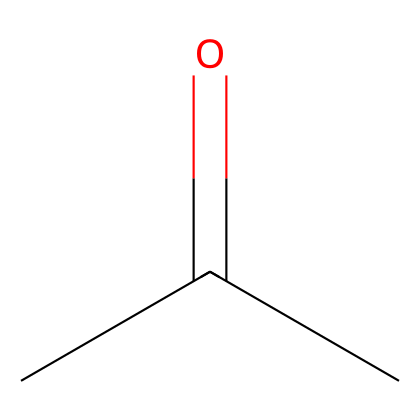What is the molecular formula of the chemical represented by the SMILES? To determine the molecular formula, we can interpret the SMILES notation. The notation "CC(=O)C" indicates there are three carbon atoms (C), one oxygen atom (O), and six hydrogen atoms (H) overall, giving the molecular formula C3H6O.
Answer: C3H6O How many hydrogen atoms are present in this molecule? By analyzing the molecular structure derived from the SMILES, we see that there are six hydrogen atoms bonded to three carbon atoms and one oxygen atom.
Answer: 6 What type of functional group is present in this chemical? The presence of the carbonyl group (C=O) in the structural formula indicates that this chemical has a ketone functional group. Thus, it can be classified as a ketone.
Answer: ketone Is acetone considered a flammable liquid? Acetone is indeed classified as a flammable liquid due to its low flash point and high volatility, which makes it capable of igniting easily.
Answer: yes What is the saturation level of the carbon atoms in this molecule? The carbon atoms in acetone are fully saturated with hydrogen atoms except for the carbonyl carbon which is involved in a double bond with oxygen, indicating that it is a saturated molecule overall with one unsaturation due to the carbonyl.
Answer: saturated What laboratory application is acetone primarily used for? Acetone is primarily used as a solvent for cleaning laboratory glassware owing to its effective ability to dissolve a wide variety of organic compounds and residues.
Answer: cleaning 